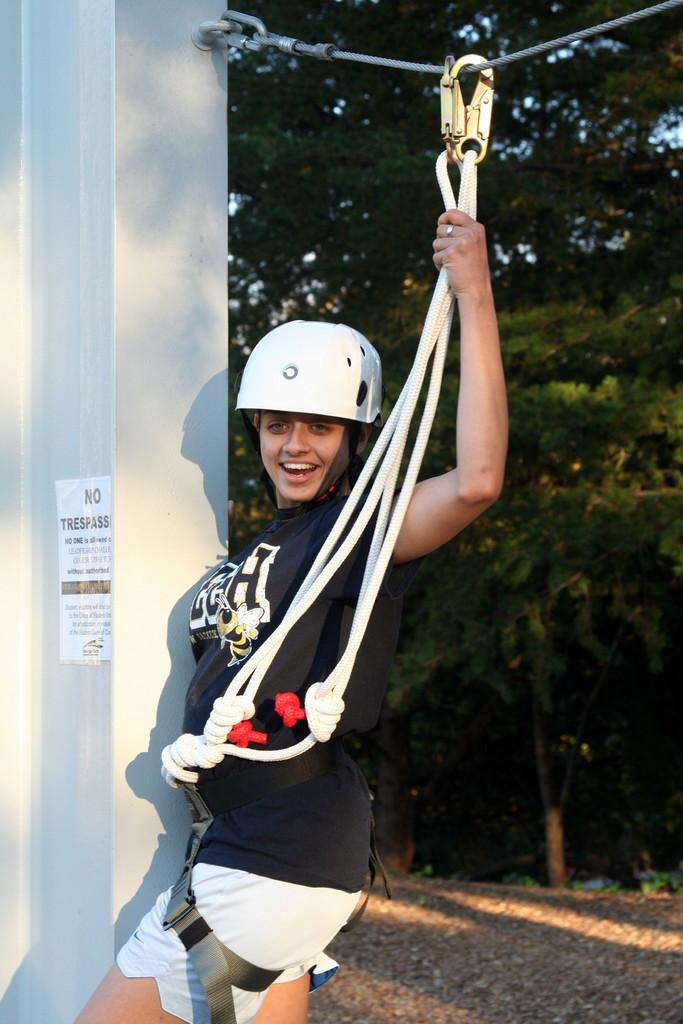Who is present in the image? There is a woman in the image. What is the woman doing in the image? The woman is standing and smiling. What is the woman holding in the image? The woman is holding a rope. How is the rope connected in the image? The rope is attached to another rope. What can be seen in the background of the image? There are trees and the sky visible in the background. What type of meat can be seen hanging from the trees in the image? There is no meat hanging from the trees in the image; it only features a woman holding a rope and trees in the background. 